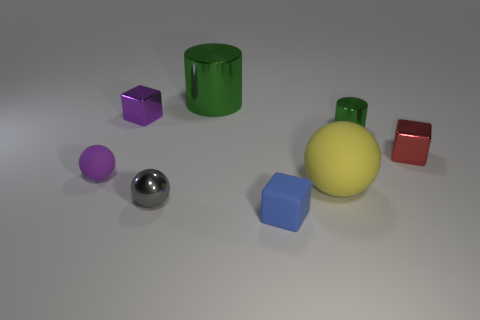Add 1 large yellow spheres. How many objects exist? 9 Subtract all spheres. How many objects are left? 5 Add 2 large matte balls. How many large matte balls are left? 3 Add 5 rubber spheres. How many rubber spheres exist? 7 Subtract 1 purple spheres. How many objects are left? 7 Subtract all gray balls. Subtract all large yellow matte balls. How many objects are left? 6 